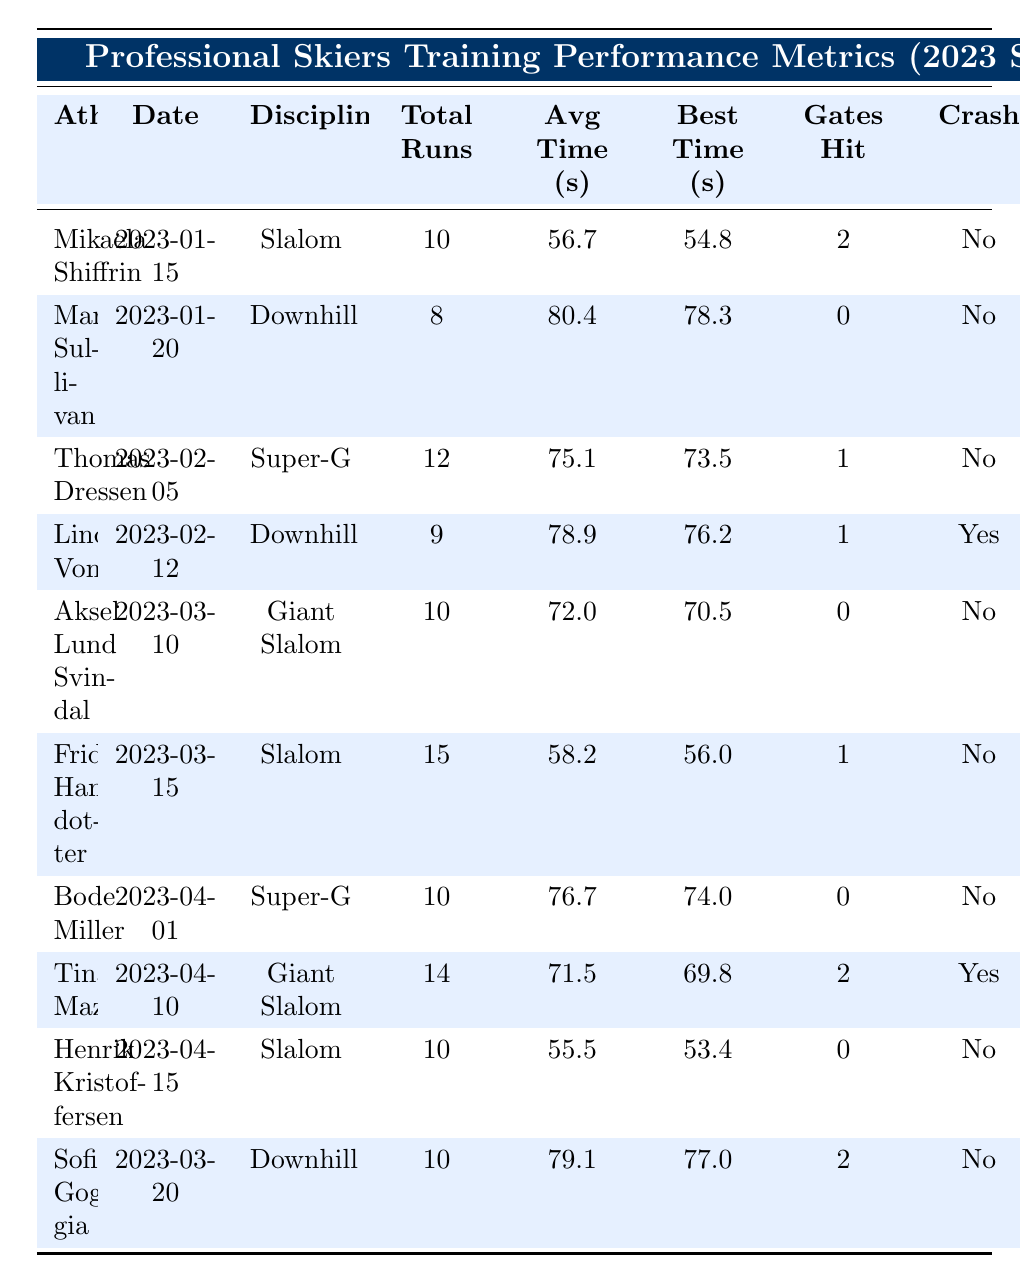What is the best time achieved by Mikaela Shiffrin in Slalom? By checking Mikaela Shiffrin's entry in the table, her best time for Slalom is listed as 54.8 seconds.
Answer: 54.8 seconds How many total runs did Lindsey Vonn complete in her Downhill training? Lindsey Vonn's row shows she completed a total of 9 runs in her Downhill training.
Answer: 9 runs Which athlete had a crash during their training session? Looking through the table, both Lindsey Vonn and Tina Maze are marked with "Yes" for crash, indicating they had a crash in their training sessions.
Answer: Lindsey Vonn and Tina Maze What is the average time for Frida Hansdotter in Slalom? Frida Hansdotter's average time is stated as 58.2 seconds in the table.
Answer: 58.2 seconds How many athletes had a total of more than 10 training runs? By counting the entries, only Frida Hansdotter (15 runs) and Tina Maze (14 runs) have total runs greater than 10, making it 2 athletes in total.
Answer: 2 athletes What is the quickest best time in Super-G among the listed athletes? Comparing the best times in Super-G for Thomas Dressen (73.5 seconds) and Bode Miller (74.0 seconds), Thomas Dressen has the quickest best time.
Answer: 73.5 seconds What is the total number of gates hit by all athletes in Giant Slalom? The table shows Aksel Lund Svindal hit 0 gates and Tina Maze hit 2 gates, so the total gates hit is 0 + 2 = 2.
Answer: 2 gates Who had the longest off time after their training session? By assessing the off time values, Tina Maze had the longest off time of 5 hours.
Answer: 5 hours Which athlete had the highest average time and in what discipline? By reviewing the average times, Marco Sullivan's average of 80.4 seconds in Downhill is the highest among all shown in the table.
Answer: Marco Sullivan, Downhill How does the average time of Henrik Kristoffersen compare to that of Mikaela Shiffrin in Slalom? Henrik Kristoffersen's average time is 55.5 seconds while Mikaela Shiffrin's is 56.7 seconds. Since 55.5 is less than 56.7, Henrik's time is quicker.
Answer: Henrik Kristoffersen is quicker 